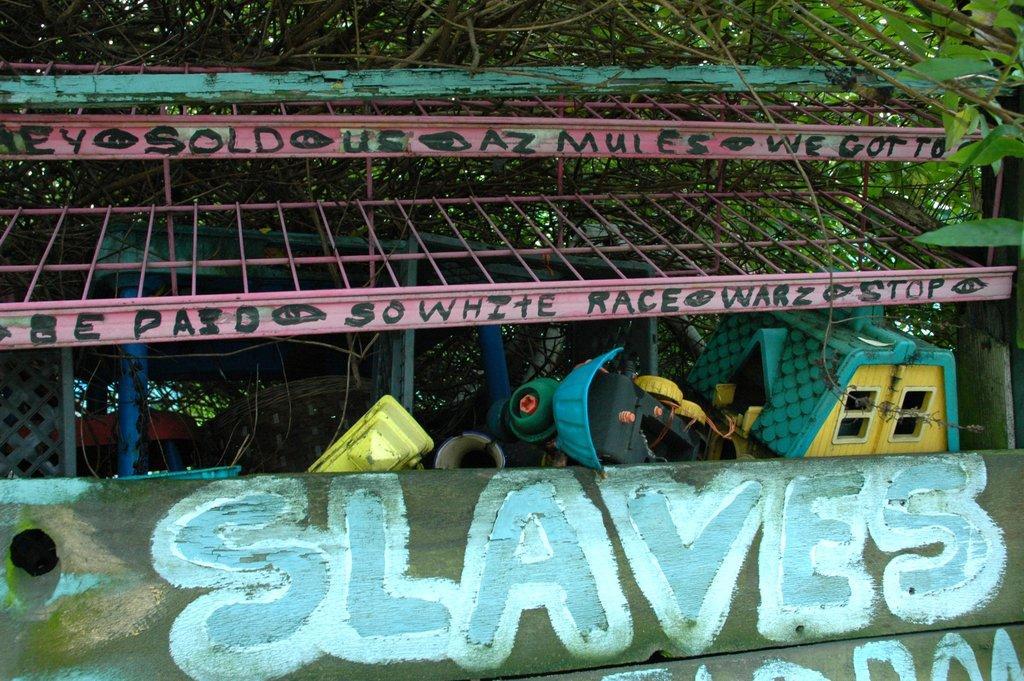Describe this image in one or two sentences. At the bottom of the picture, we see a wooden board with some text written on it. Behind that, we see toys which are in yellow, blue and green color. At the top, we see a pink color thing which looks like the roof of the shed. There are trees in the background. 